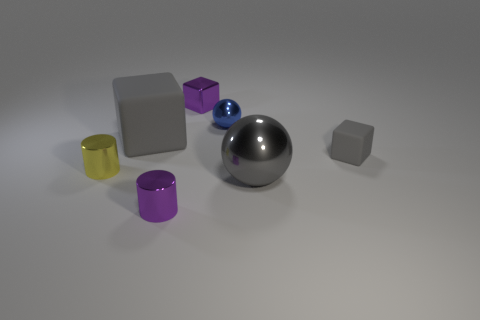Add 1 gray shiny blocks. How many objects exist? 8 Subtract all balls. How many objects are left? 5 Subtract all yellow matte cylinders. Subtract all small purple metallic cylinders. How many objects are left? 6 Add 5 gray blocks. How many gray blocks are left? 7 Add 1 large metal blocks. How many large metal blocks exist? 1 Subtract 0 cyan cylinders. How many objects are left? 7 